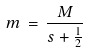<formula> <loc_0><loc_0><loc_500><loc_500>m \, = \, \frac { M } { s + \frac { 1 } { 2 } }</formula> 